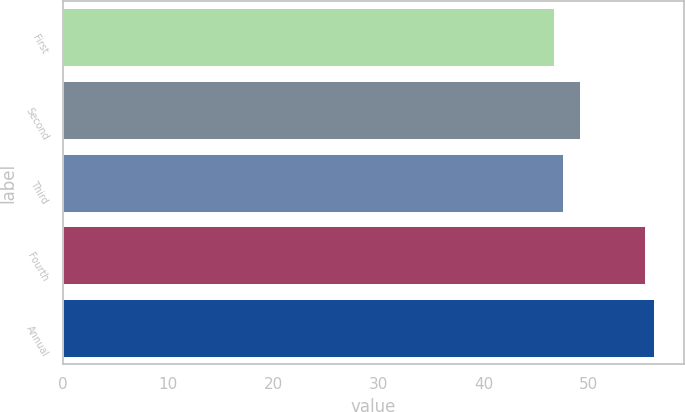<chart> <loc_0><loc_0><loc_500><loc_500><bar_chart><fcel>First<fcel>Second<fcel>Third<fcel>Fourth<fcel>Annual<nl><fcel>46.76<fcel>49.21<fcel>47.62<fcel>55.39<fcel>56.25<nl></chart> 